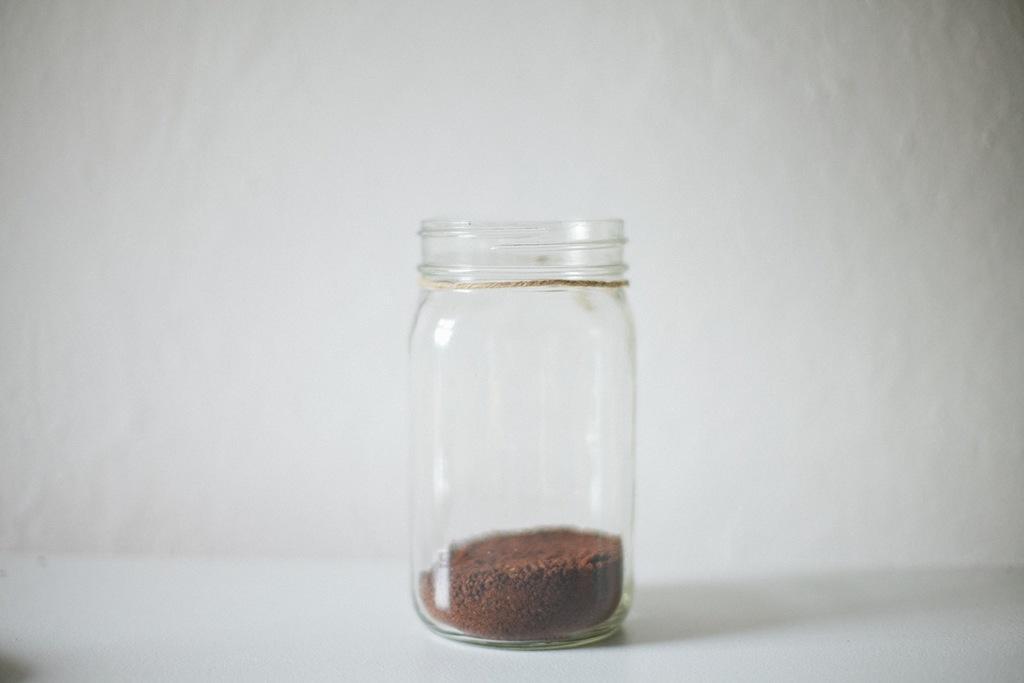Can you describe this image briefly? It is a glass tumbler in which there is some soil at the bottom. 